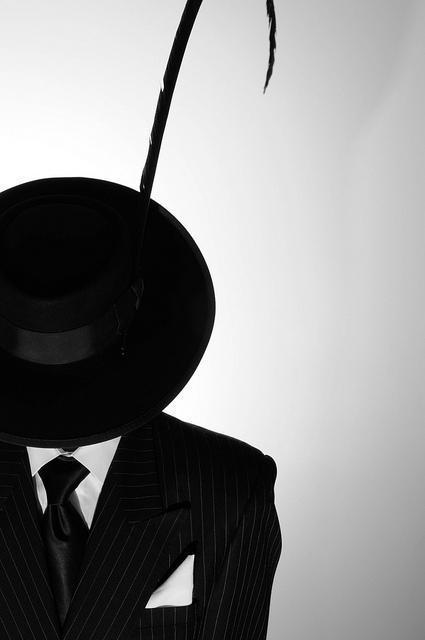How many of the train cars are yellow and red?
Give a very brief answer. 0. 